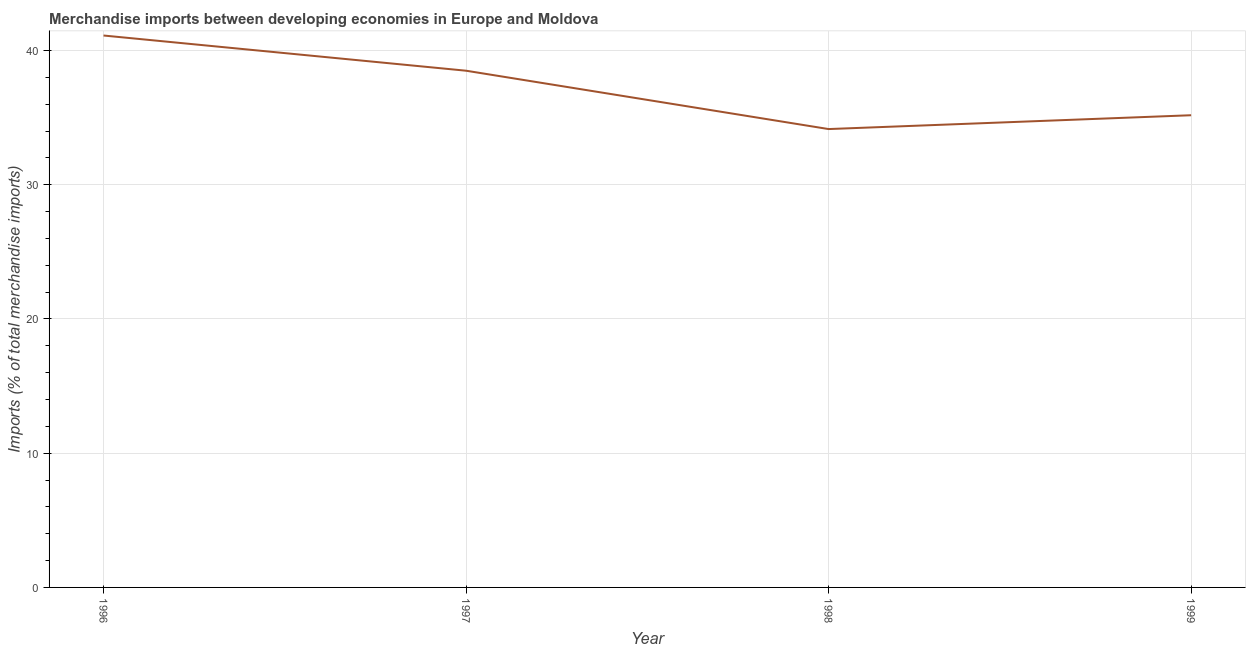What is the merchandise imports in 1999?
Your answer should be very brief. 35.18. Across all years, what is the maximum merchandise imports?
Offer a very short reply. 41.12. Across all years, what is the minimum merchandise imports?
Make the answer very short. 34.15. In which year was the merchandise imports maximum?
Your answer should be very brief. 1996. In which year was the merchandise imports minimum?
Offer a very short reply. 1998. What is the sum of the merchandise imports?
Offer a terse response. 148.94. What is the difference between the merchandise imports in 1997 and 1999?
Offer a very short reply. 3.32. What is the average merchandise imports per year?
Provide a succinct answer. 37.24. What is the median merchandise imports?
Make the answer very short. 36.84. In how many years, is the merchandise imports greater than 16 %?
Ensure brevity in your answer.  4. What is the ratio of the merchandise imports in 1998 to that in 1999?
Your response must be concise. 0.97. Is the merchandise imports in 1997 less than that in 1998?
Offer a very short reply. No. What is the difference between the highest and the second highest merchandise imports?
Ensure brevity in your answer.  2.62. Is the sum of the merchandise imports in 1997 and 1999 greater than the maximum merchandise imports across all years?
Give a very brief answer. Yes. What is the difference between the highest and the lowest merchandise imports?
Ensure brevity in your answer.  6.97. In how many years, is the merchandise imports greater than the average merchandise imports taken over all years?
Your answer should be very brief. 2. Does the merchandise imports monotonically increase over the years?
Offer a very short reply. No. How many lines are there?
Your answer should be compact. 1. Are the values on the major ticks of Y-axis written in scientific E-notation?
Offer a terse response. No. Does the graph contain any zero values?
Give a very brief answer. No. Does the graph contain grids?
Offer a terse response. Yes. What is the title of the graph?
Your response must be concise. Merchandise imports between developing economies in Europe and Moldova. What is the label or title of the Y-axis?
Provide a short and direct response. Imports (% of total merchandise imports). What is the Imports (% of total merchandise imports) in 1996?
Your response must be concise. 41.12. What is the Imports (% of total merchandise imports) in 1997?
Provide a succinct answer. 38.5. What is the Imports (% of total merchandise imports) of 1998?
Your response must be concise. 34.15. What is the Imports (% of total merchandise imports) of 1999?
Ensure brevity in your answer.  35.18. What is the difference between the Imports (% of total merchandise imports) in 1996 and 1997?
Your response must be concise. 2.62. What is the difference between the Imports (% of total merchandise imports) in 1996 and 1998?
Make the answer very short. 6.97. What is the difference between the Imports (% of total merchandise imports) in 1996 and 1999?
Keep it short and to the point. 5.94. What is the difference between the Imports (% of total merchandise imports) in 1997 and 1998?
Make the answer very short. 4.35. What is the difference between the Imports (% of total merchandise imports) in 1997 and 1999?
Ensure brevity in your answer.  3.32. What is the difference between the Imports (% of total merchandise imports) in 1998 and 1999?
Your response must be concise. -1.03. What is the ratio of the Imports (% of total merchandise imports) in 1996 to that in 1997?
Give a very brief answer. 1.07. What is the ratio of the Imports (% of total merchandise imports) in 1996 to that in 1998?
Give a very brief answer. 1.2. What is the ratio of the Imports (% of total merchandise imports) in 1996 to that in 1999?
Ensure brevity in your answer.  1.17. What is the ratio of the Imports (% of total merchandise imports) in 1997 to that in 1998?
Offer a very short reply. 1.13. What is the ratio of the Imports (% of total merchandise imports) in 1997 to that in 1999?
Provide a succinct answer. 1.09. What is the ratio of the Imports (% of total merchandise imports) in 1998 to that in 1999?
Ensure brevity in your answer.  0.97. 